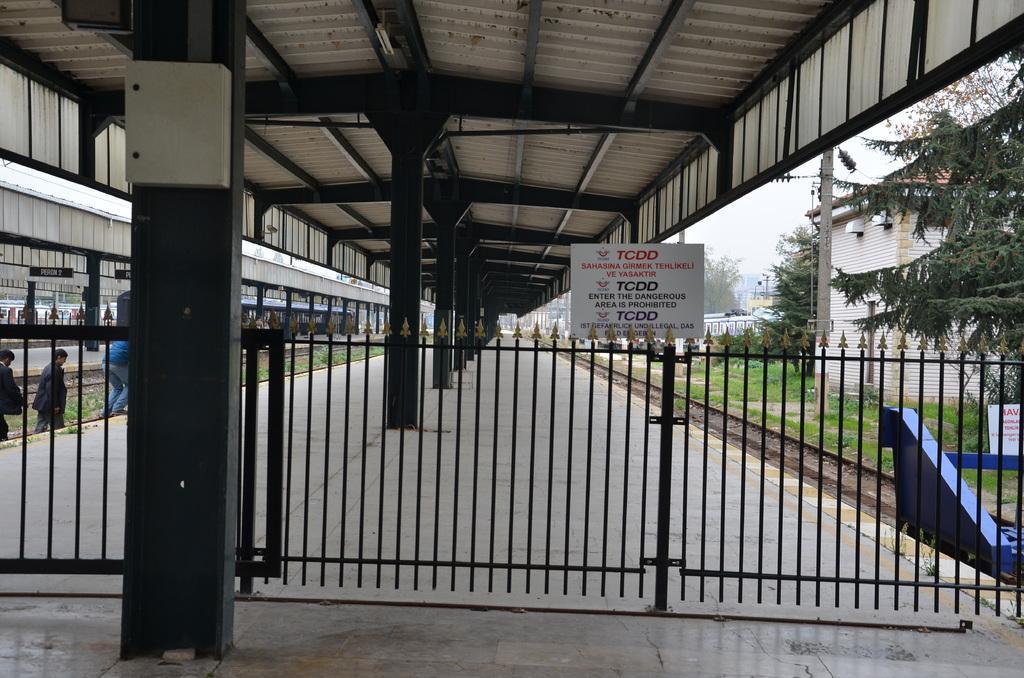In one or two sentences, can you explain what this image depicts? In this image, there are a few people. We can see the fence. We can see some pillars and poles. We can see some boards with text. We can see some grass, plants and trees. There are a few houses. We can see the sky. We can see the railway track. 